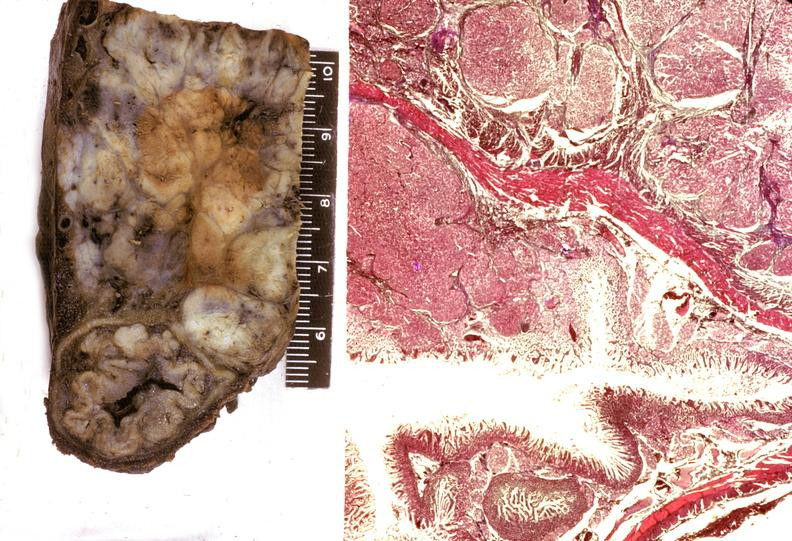s pancreas present?
Answer the question using a single word or phrase. Yes 